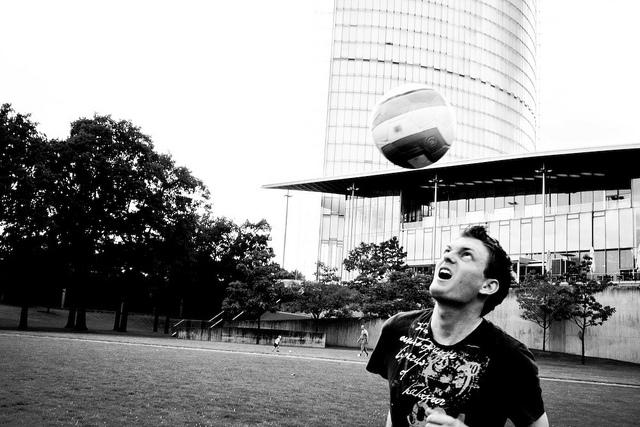What type of ball is that?
Quick response, please. Soccer. Is this photo in color?
Write a very short answer. No. Is the man in the picture about to kick the ball?
Give a very brief answer. No. 